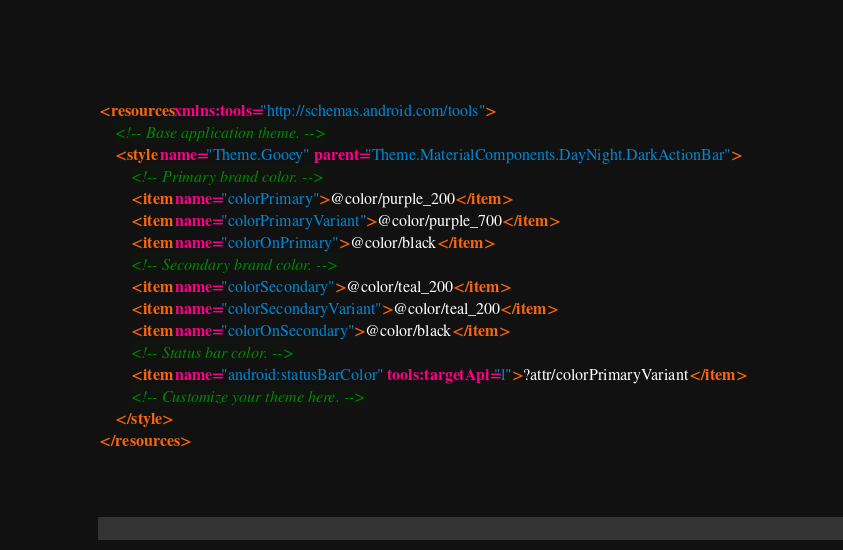<code> <loc_0><loc_0><loc_500><loc_500><_XML_><resources xmlns:tools="http://schemas.android.com/tools">
    <!-- Base application theme. -->
    <style name="Theme.Gooey" parent="Theme.MaterialComponents.DayNight.DarkActionBar">
        <!-- Primary brand color. -->
        <item name="colorPrimary">@color/purple_200</item>
        <item name="colorPrimaryVariant">@color/purple_700</item>
        <item name="colorOnPrimary">@color/black</item>
        <!-- Secondary brand color. -->
        <item name="colorSecondary">@color/teal_200</item>
        <item name="colorSecondaryVariant">@color/teal_200</item>
        <item name="colorOnSecondary">@color/black</item>
        <!-- Status bar color. -->
        <item name="android:statusBarColor" tools:targetApi="l">?attr/colorPrimaryVariant</item>
        <!-- Customize your theme here. -->
    </style>
</resources></code> 